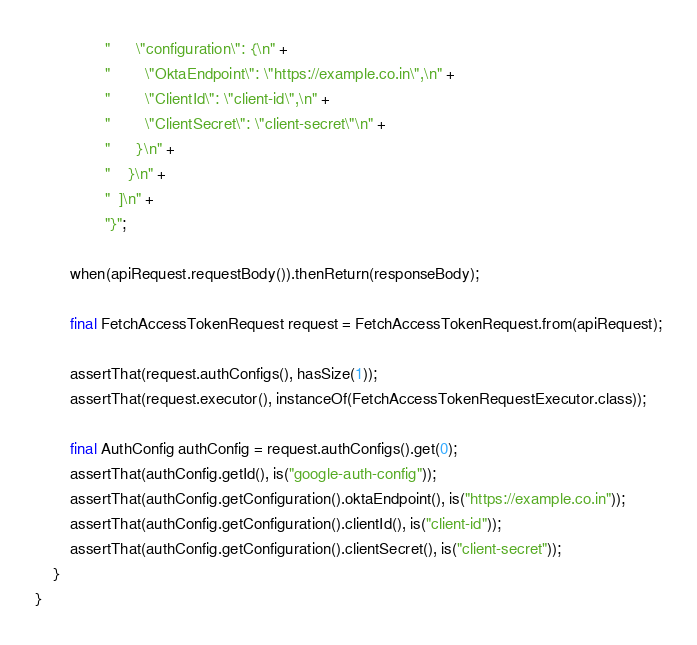Convert code to text. <code><loc_0><loc_0><loc_500><loc_500><_Java_>                "      \"configuration\": {\n" +
                "        \"OktaEndpoint\": \"https://example.co.in\",\n" +
                "        \"ClientId\": \"client-id\",\n" +
                "        \"ClientSecret\": \"client-secret\"\n" +
                "      }\n" +
                "    }\n" +
                "  ]\n" +
                "}";

        when(apiRequest.requestBody()).thenReturn(responseBody);

        final FetchAccessTokenRequest request = FetchAccessTokenRequest.from(apiRequest);

        assertThat(request.authConfigs(), hasSize(1));
        assertThat(request.executor(), instanceOf(FetchAccessTokenRequestExecutor.class));

        final AuthConfig authConfig = request.authConfigs().get(0);
        assertThat(authConfig.getId(), is("google-auth-config"));
        assertThat(authConfig.getConfiguration().oktaEndpoint(), is("https://example.co.in"));
        assertThat(authConfig.getConfiguration().clientId(), is("client-id"));
        assertThat(authConfig.getConfiguration().clientSecret(), is("client-secret"));
    }
}
</code> 